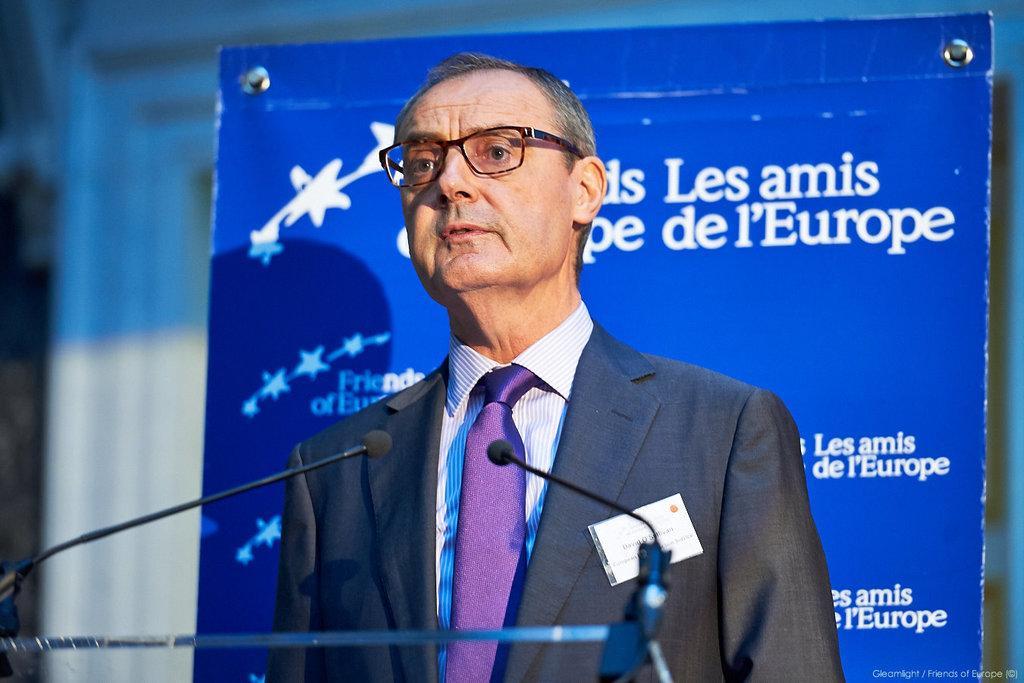Please provide a concise description of this image. In this picture we can observe a person wearing a coat, shirt and a tie, standing in front of a podium on which there are two mics. He is wearing spectacles. In the background we can observe a blue color poster. There are white color words on the blue color poster. 